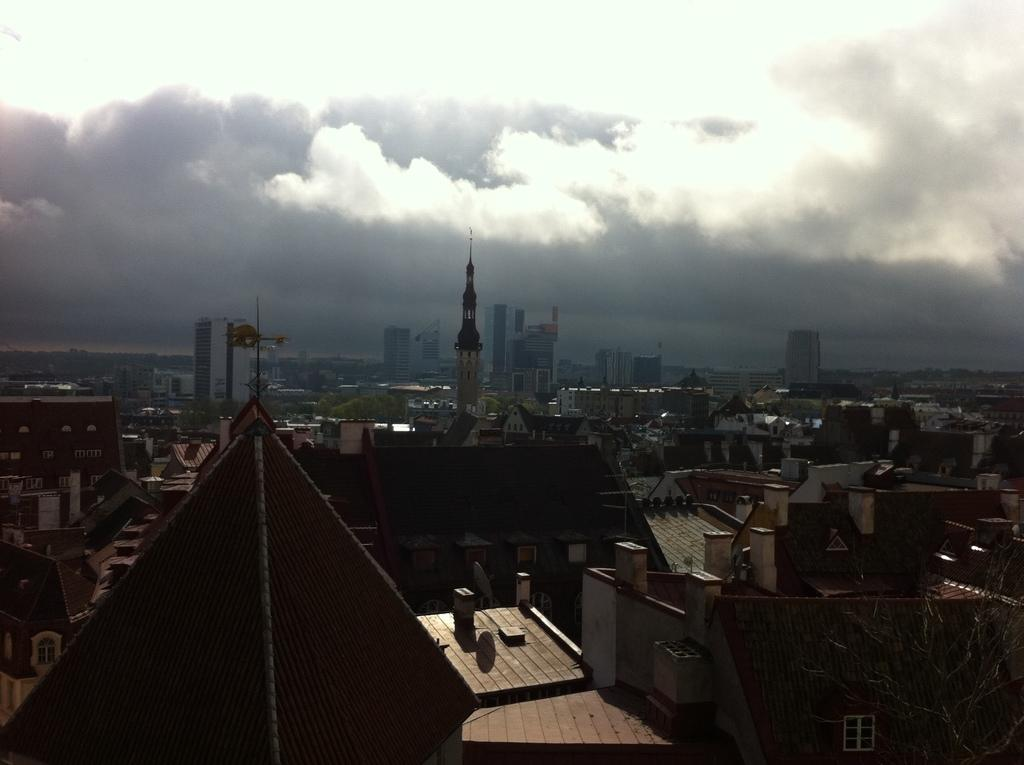What type of structures can be seen in the image? There are many houses, buildings, and other architectures in the image. Are there any natural elements present in the image? Yes, there are trees in the image. What type of treatment is being administered to the butter in the image? There is no butter present in the image, so no treatment can be administered to it. 